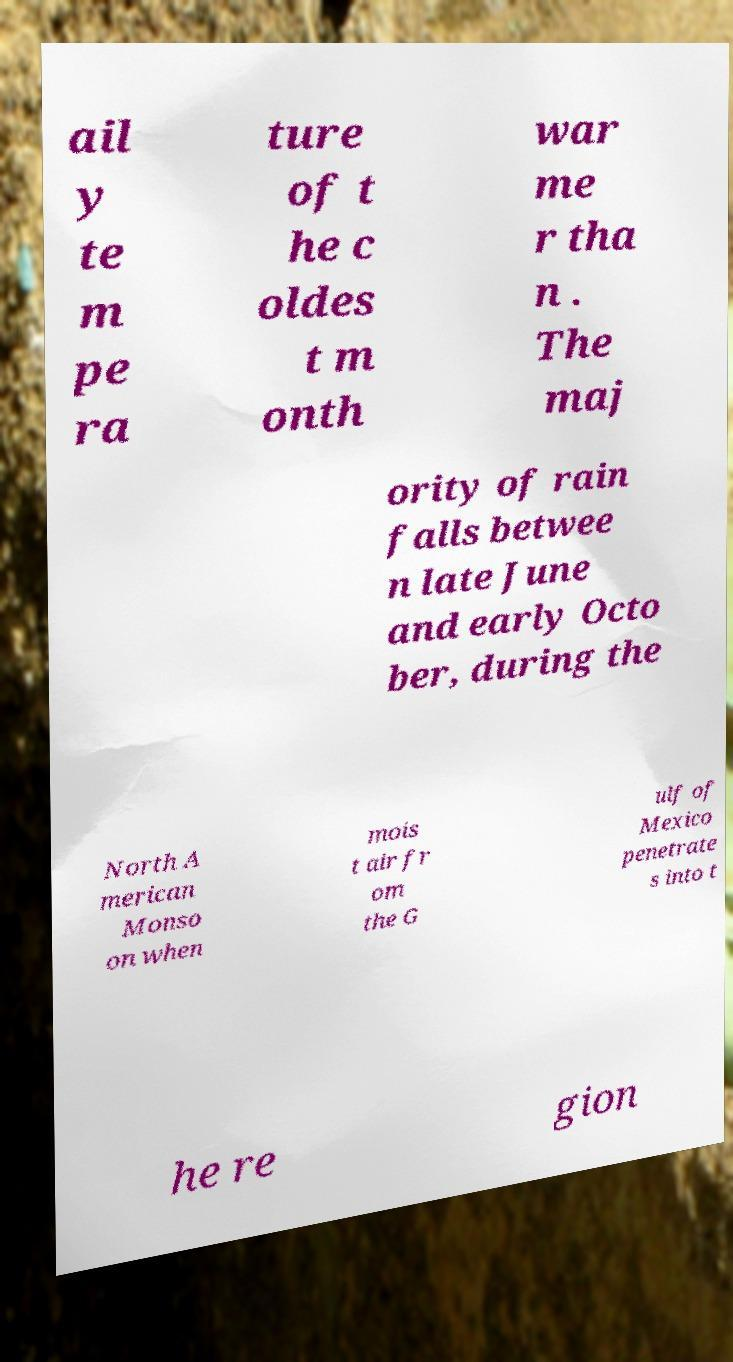Can you accurately transcribe the text from the provided image for me? ail y te m pe ra ture of t he c oldes t m onth war me r tha n . The maj ority of rain falls betwee n late June and early Octo ber, during the North A merican Monso on when mois t air fr om the G ulf of Mexico penetrate s into t he re gion 